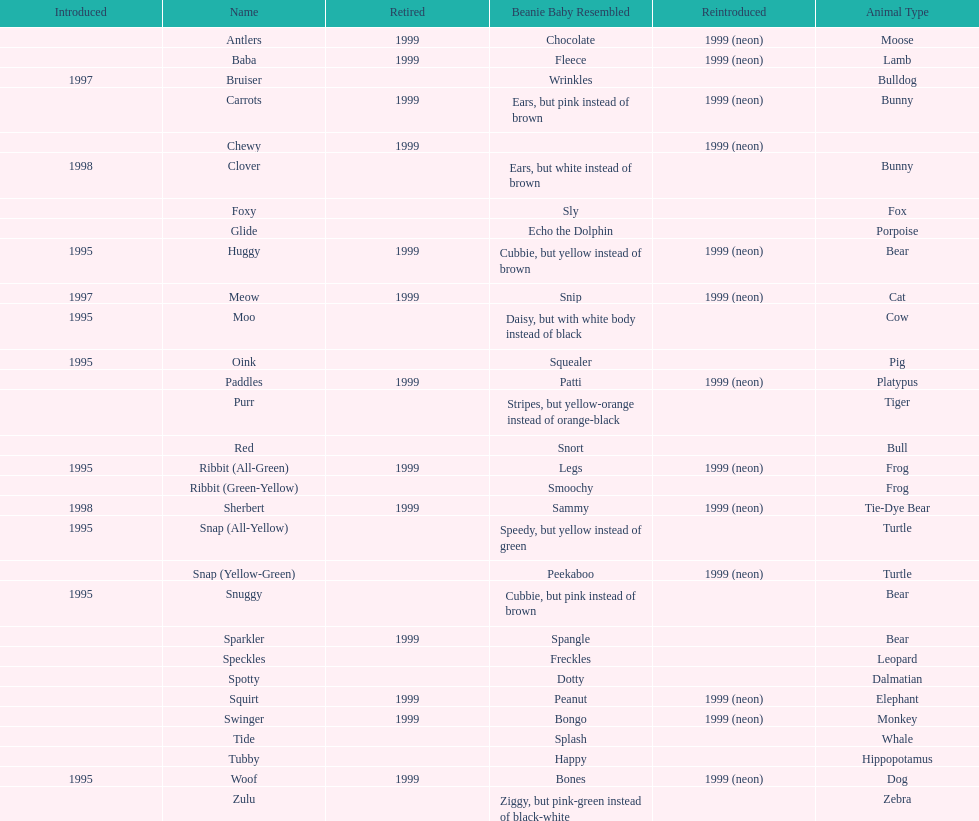Name the only pillow pal that is a dalmatian. Spotty. 